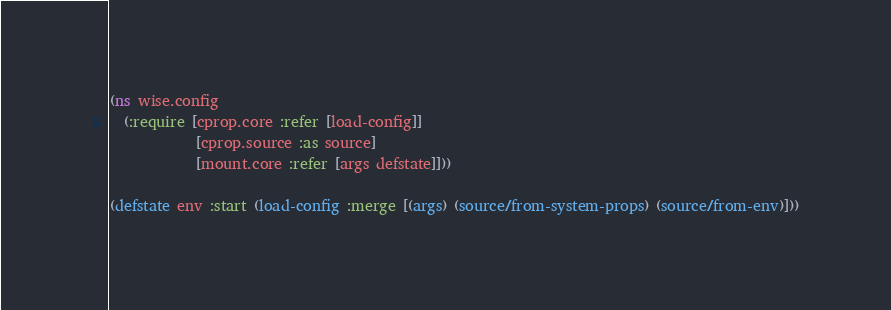<code> <loc_0><loc_0><loc_500><loc_500><_Clojure_>(ns wise.config
  (:require [cprop.core :refer [load-config]]
            [cprop.source :as source]
            [mount.core :refer [args defstate]]))

(defstate env :start (load-config :merge [(args) (source/from-system-props) (source/from-env)]))
</code> 